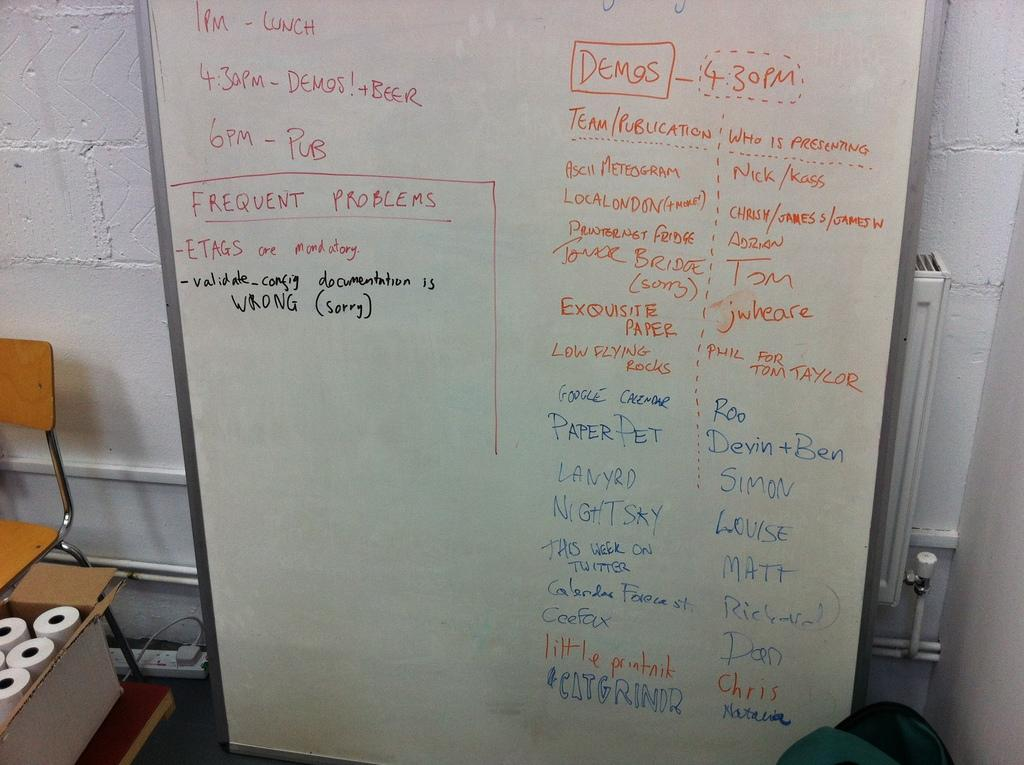<image>
Present a compact description of the photo's key features. A white board has a schedule written on it with Demos listed at 4:30 pm. 